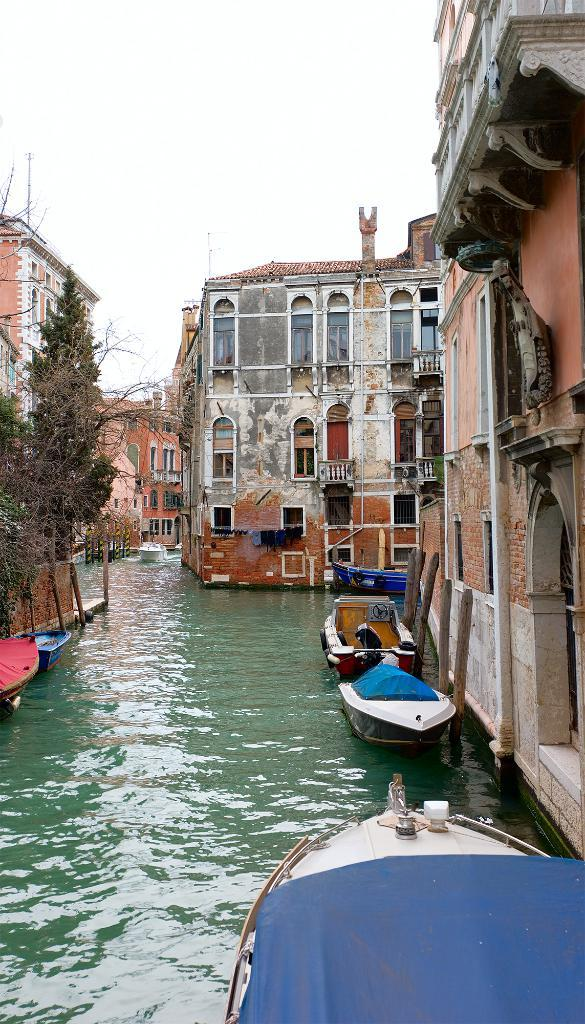What is on the water in the image? There are boats on the water in the image. What type of vegetation can be seen in the image? Trees are visible in the image. What kind of structures are present in the image? There are buildings with windows in the image. What is visible in the background of the image? The sky is visible in the background of the image. How many horses are grazing near the buildings in the image? There are no horses present in the image; it features boats on the water, trees, buildings with windows, and the sky. What scientific discovery is being made in the image? There is no scientific discovery being made in the image; it is a scene with boats, trees, buildings, and the sky. 